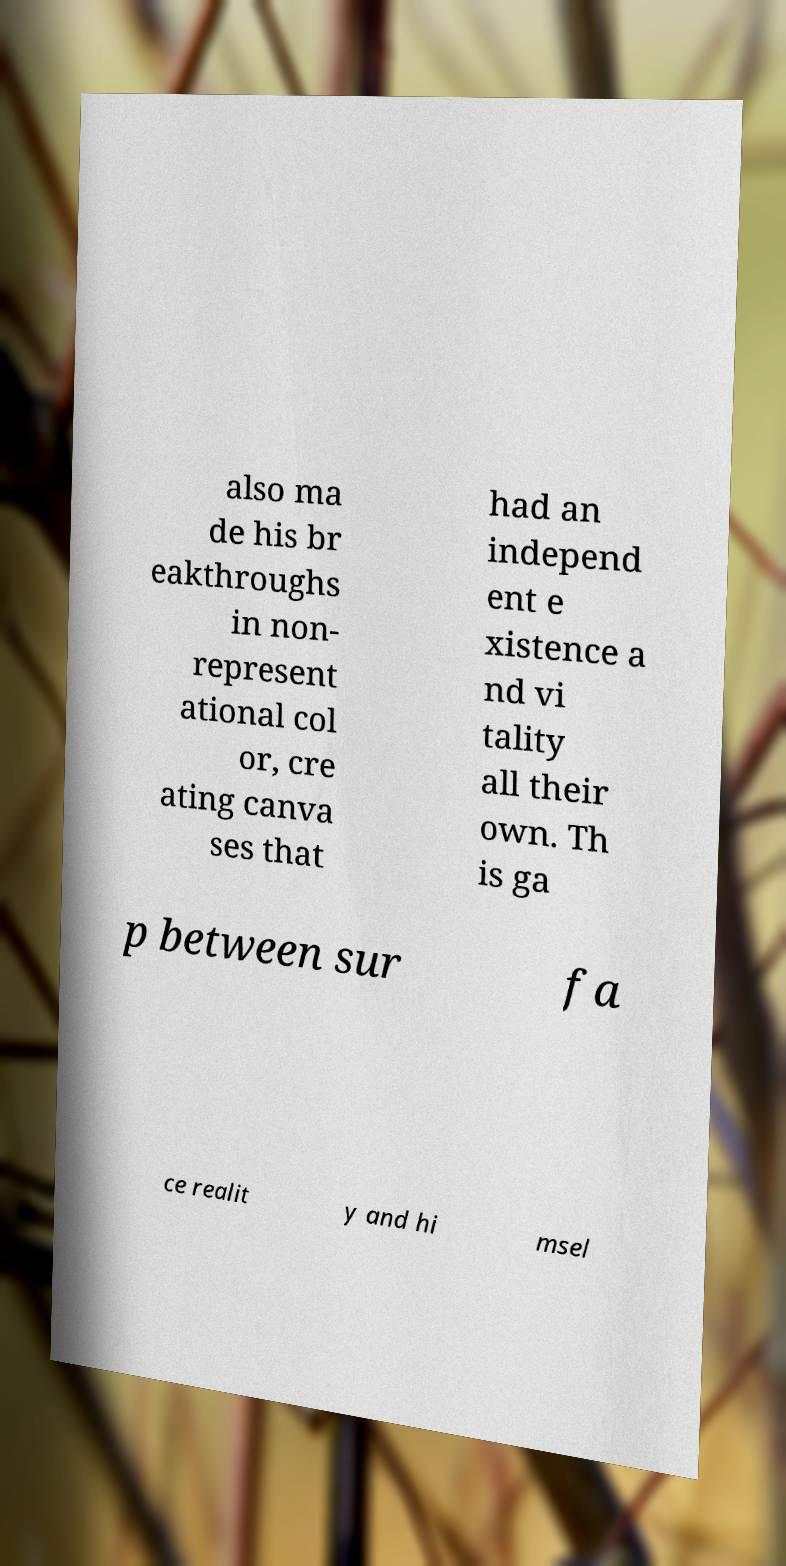Please identify and transcribe the text found in this image. also ma de his br eakthroughs in non- represent ational col or, cre ating canva ses that had an independ ent e xistence a nd vi tality all their own. Th is ga p between sur fa ce realit y and hi msel 